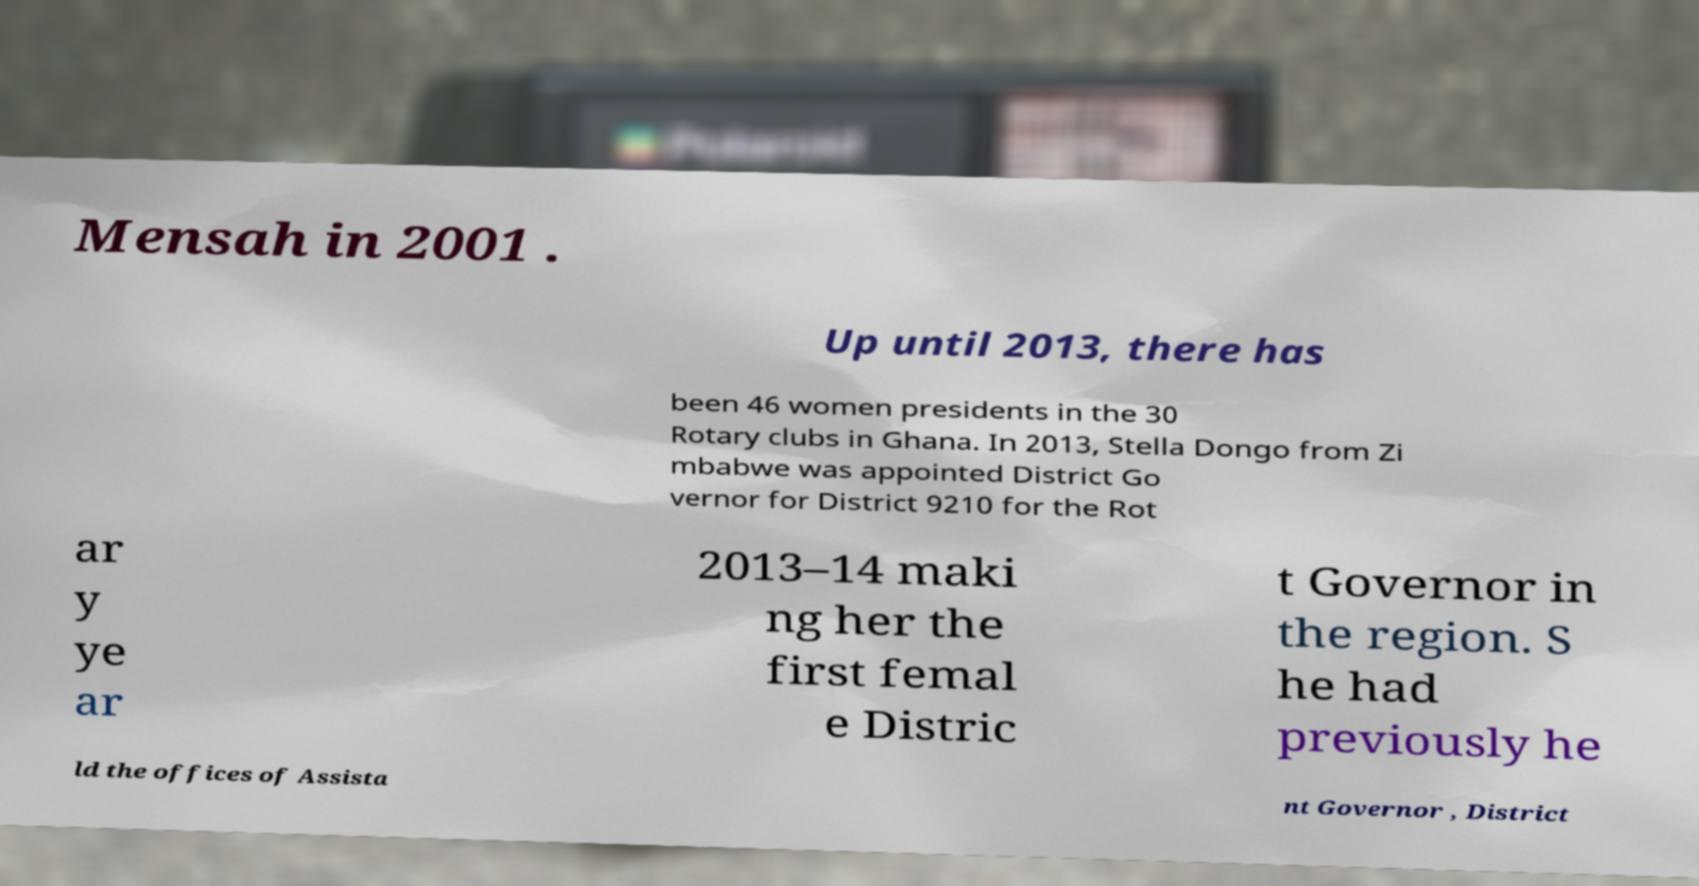Please read and relay the text visible in this image. What does it say? Mensah in 2001 . Up until 2013, there has been 46 women presidents in the 30 Rotary clubs in Ghana. In 2013, Stella Dongo from Zi mbabwe was appointed District Go vernor for District 9210 for the Rot ar y ye ar 2013–14 maki ng her the first femal e Distric t Governor in the region. S he had previously he ld the offices of Assista nt Governor , District 